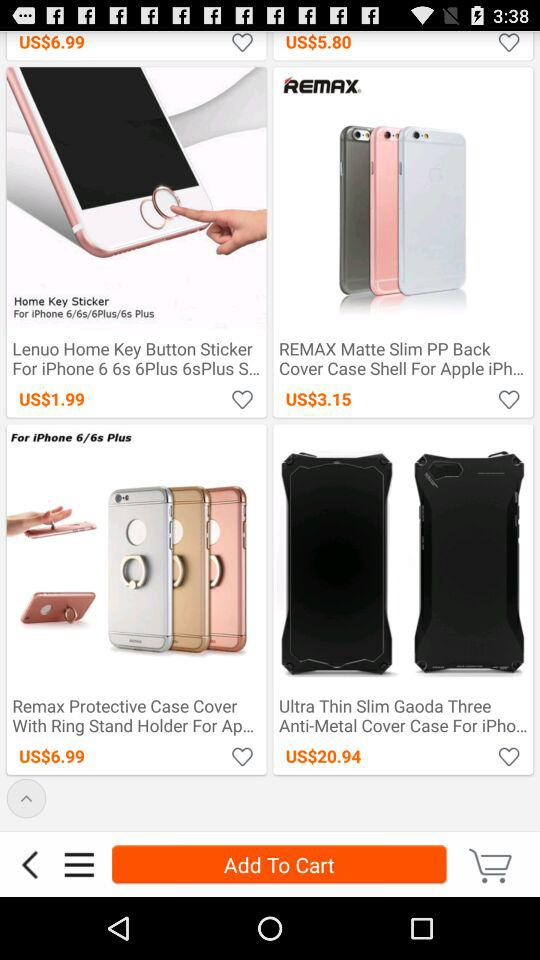Remax protective case cover is for which mobile model? It is for the iPhone 6 plus and the iPhone 6s plus. 